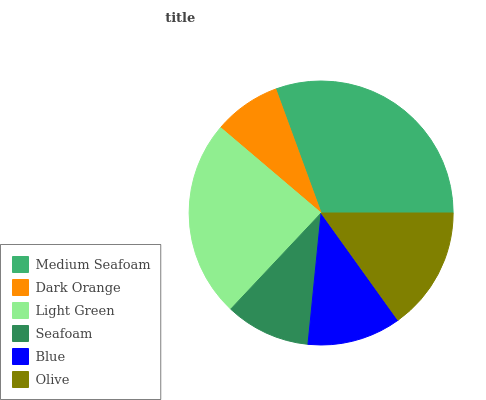Is Dark Orange the minimum?
Answer yes or no. Yes. Is Medium Seafoam the maximum?
Answer yes or no. Yes. Is Light Green the minimum?
Answer yes or no. No. Is Light Green the maximum?
Answer yes or no. No. Is Light Green greater than Dark Orange?
Answer yes or no. Yes. Is Dark Orange less than Light Green?
Answer yes or no. Yes. Is Dark Orange greater than Light Green?
Answer yes or no. No. Is Light Green less than Dark Orange?
Answer yes or no. No. Is Olive the high median?
Answer yes or no. Yes. Is Blue the low median?
Answer yes or no. Yes. Is Seafoam the high median?
Answer yes or no. No. Is Olive the low median?
Answer yes or no. No. 